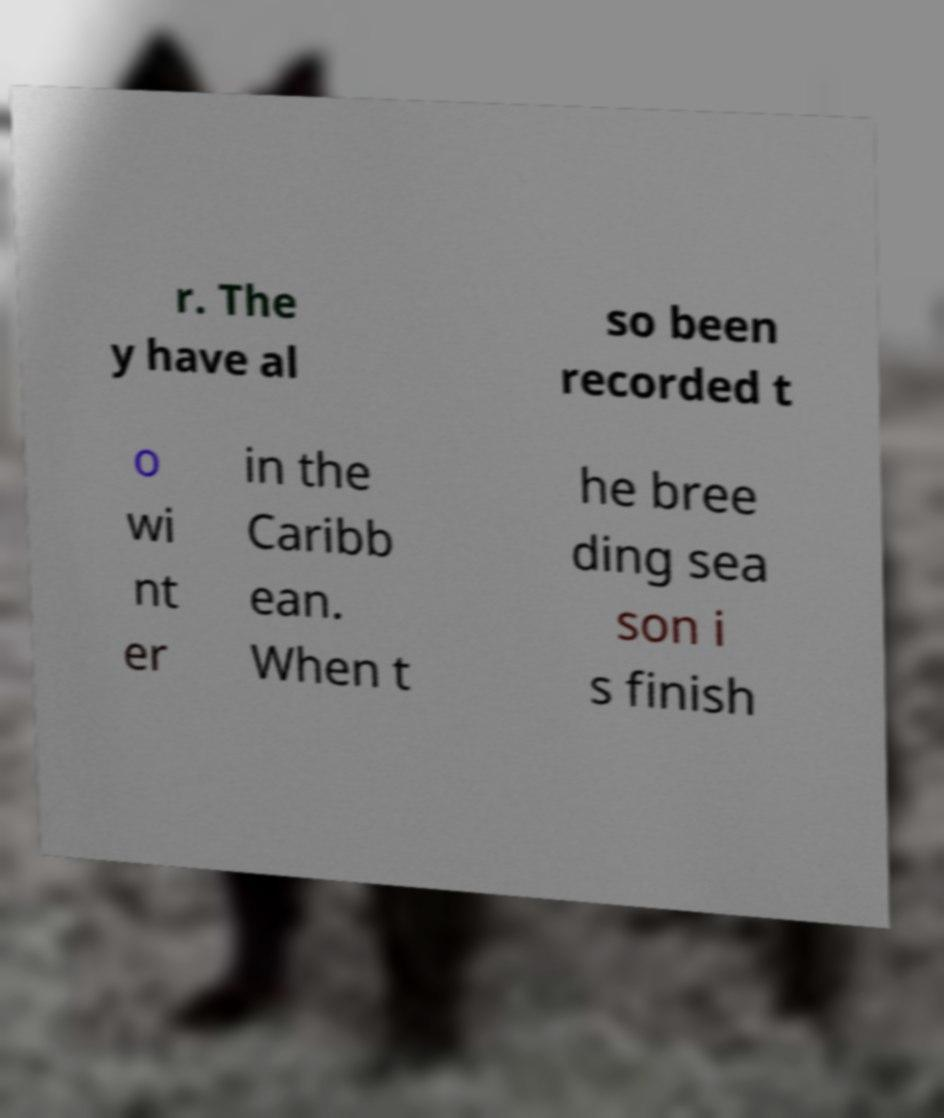For documentation purposes, I need the text within this image transcribed. Could you provide that? r. The y have al so been recorded t o wi nt er in the Caribb ean. When t he bree ding sea son i s finish 